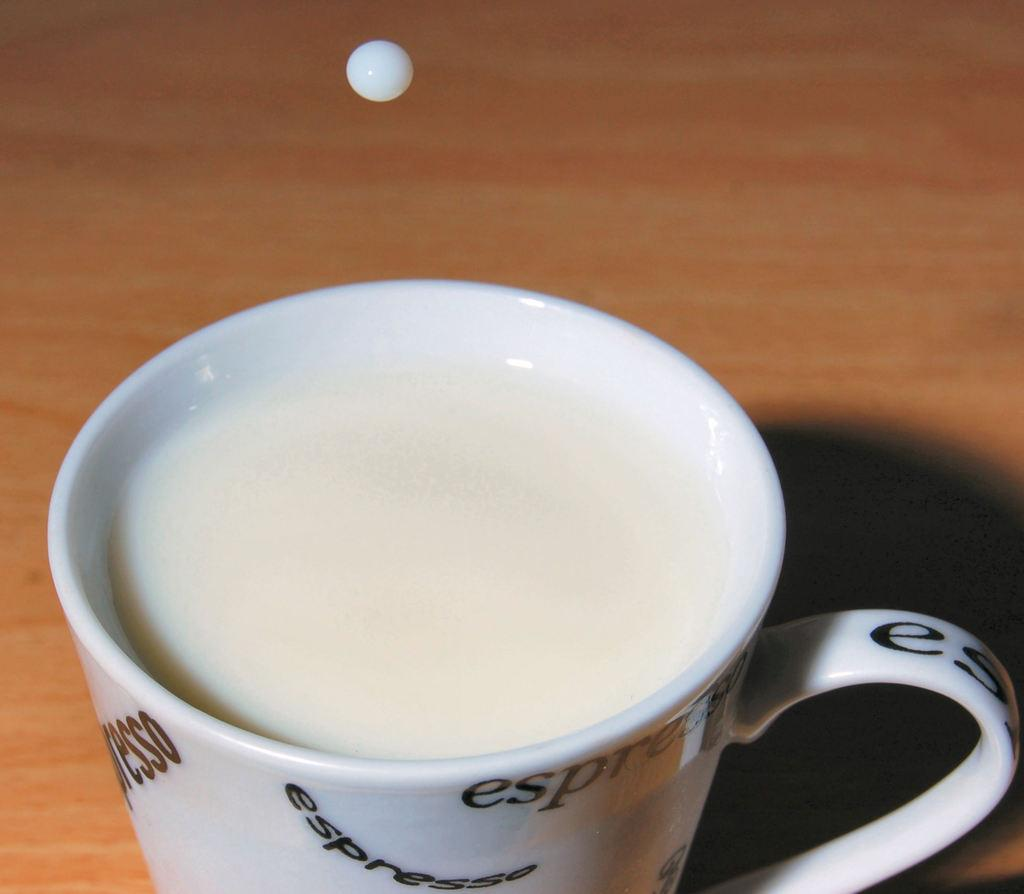What is contained in the cup that is visible in the image? There is a cup of milk in the image. What type of material is the board in the image made of? The board in the image is made of wood. Can you describe any additional details about the milk in the image? Yes, there is a drop of milk in the image. What type of feast is being prepared on the wooden board in the image? There is no feast or preparation for a feast visible in the image; it only features a cup of milk and a wooden board. 